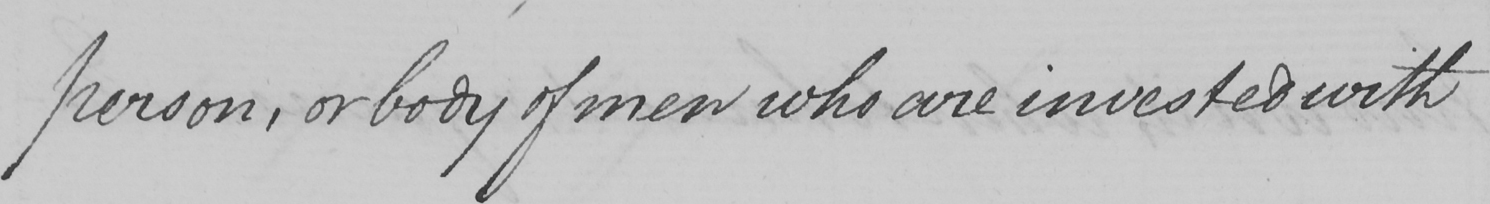Can you tell me what this handwritten text says? person, or body of men who are invested with 